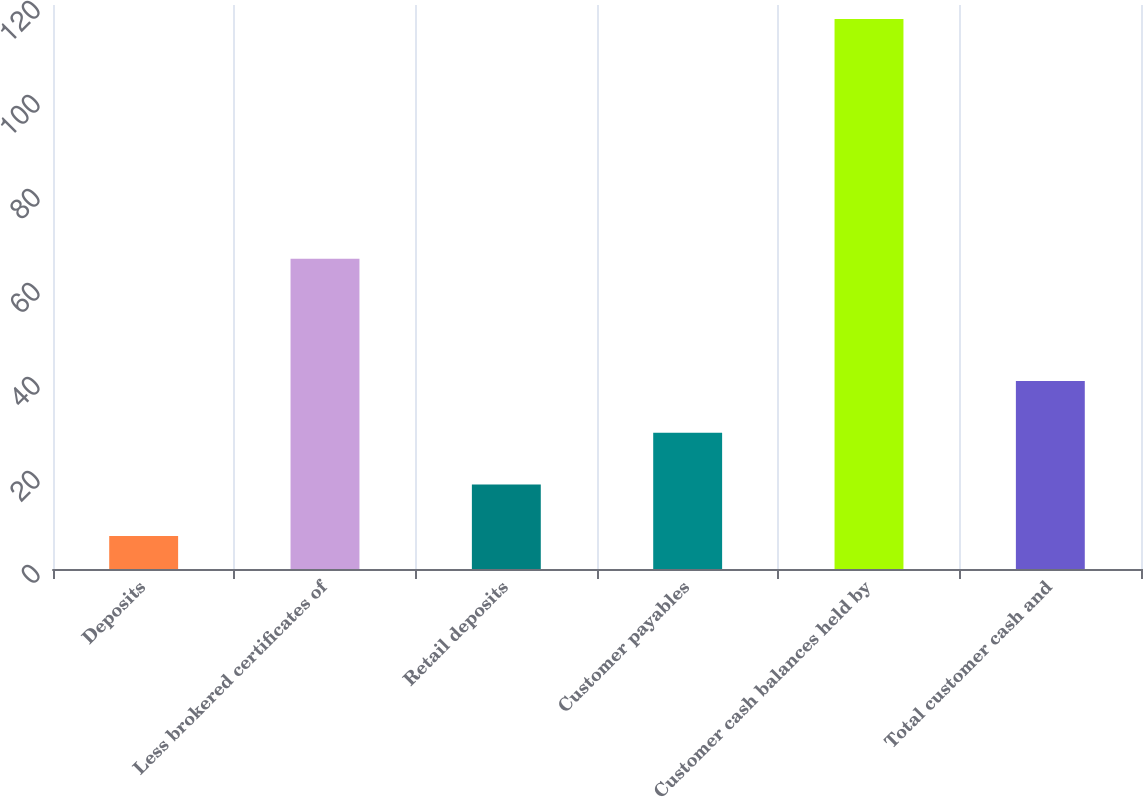Convert chart. <chart><loc_0><loc_0><loc_500><loc_500><bar_chart><fcel>Deposits<fcel>Less brokered certificates of<fcel>Retail deposits<fcel>Customer payables<fcel>Customer cash balances held by<fcel>Total customer cash and<nl><fcel>7<fcel>66<fcel>18<fcel>29<fcel>117<fcel>40<nl></chart> 